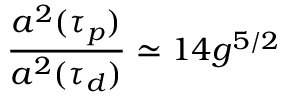Convert formula to latex. <formula><loc_0><loc_0><loc_500><loc_500>\frac { a ^ { 2 } ( \tau _ { p } ) } { a ^ { 2 } ( \tau _ { d } ) } \simeq 1 4 g ^ { 5 / 2 }</formula> 